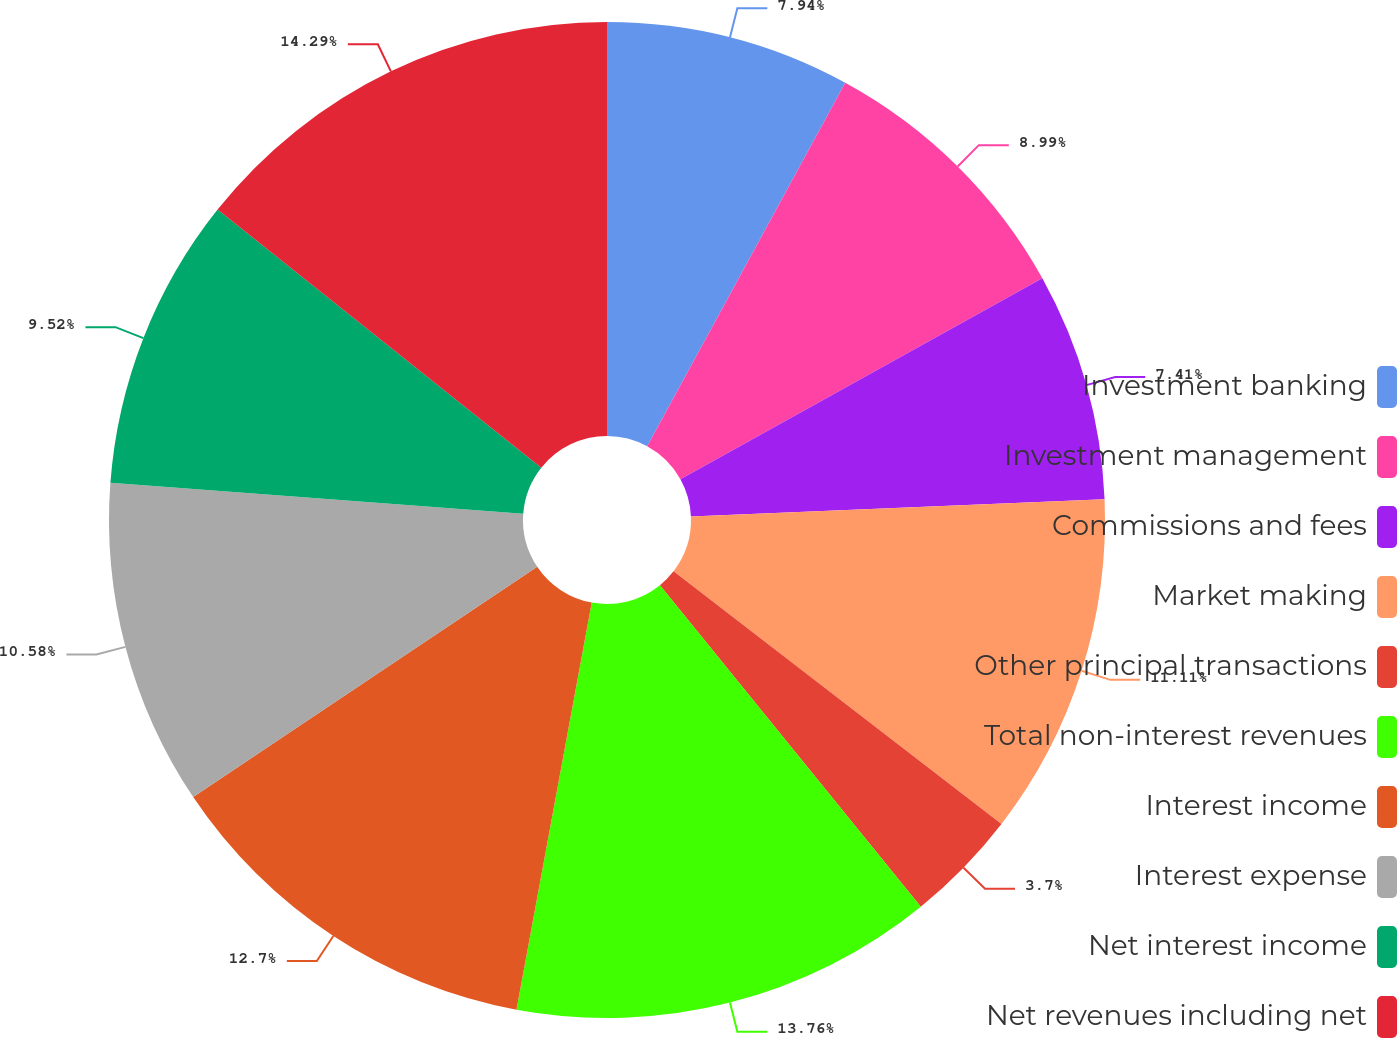<chart> <loc_0><loc_0><loc_500><loc_500><pie_chart><fcel>Investment banking<fcel>Investment management<fcel>Commissions and fees<fcel>Market making<fcel>Other principal transactions<fcel>Total non-interest revenues<fcel>Interest income<fcel>Interest expense<fcel>Net interest income<fcel>Net revenues including net<nl><fcel>7.94%<fcel>8.99%<fcel>7.41%<fcel>11.11%<fcel>3.7%<fcel>13.76%<fcel>12.7%<fcel>10.58%<fcel>9.52%<fcel>14.29%<nl></chart> 